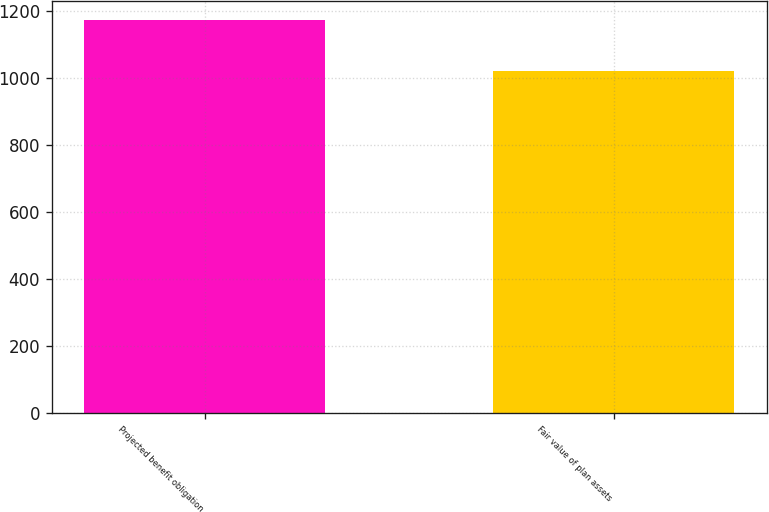<chart> <loc_0><loc_0><loc_500><loc_500><bar_chart><fcel>Projected benefit obligation<fcel>Fair value of plan assets<nl><fcel>1172<fcel>1021<nl></chart> 